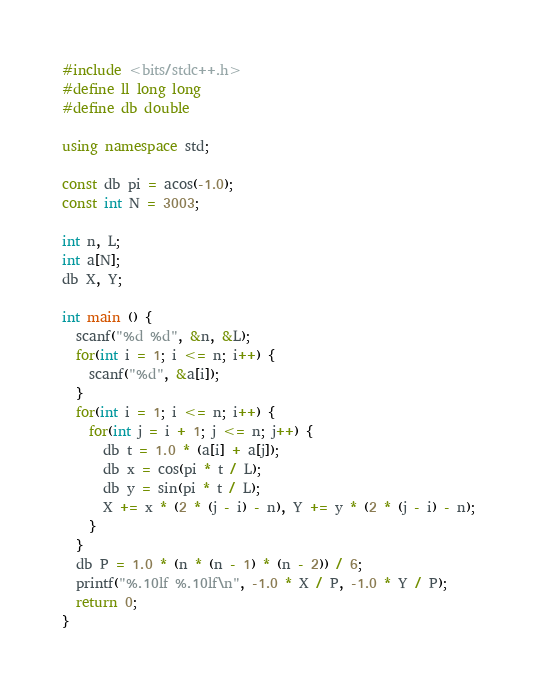<code> <loc_0><loc_0><loc_500><loc_500><_C++_>#include <bits/stdc++.h>
#define ll long long
#define db double 

using namespace std;

const db pi = acos(-1.0); 
const int N = 3003; 

int n, L;
int a[N]; 
db X, Y; 

int main () {
  scanf("%d %d", &n, &L); 
  for(int i = 1; i <= n; i++) {
    scanf("%d", &a[i]); 
  }
  for(int i = 1; i <= n; i++) {
    for(int j = i + 1; j <= n; j++) {
      db t = 1.0 * (a[i] + a[j]); 
      db x = cos(pi * t / L); 
      db y = sin(pi * t / L); 
      X += x * (2 * (j - i) - n), Y += y * (2 * (j - i) - n); 
    }
  }
  db P = 1.0 * (n * (n - 1) * (n - 2)) / 6; 
  printf("%.10lf %.10lf\n", -1.0 * X / P, -1.0 * Y / P); 
  return 0; 
}
</code> 